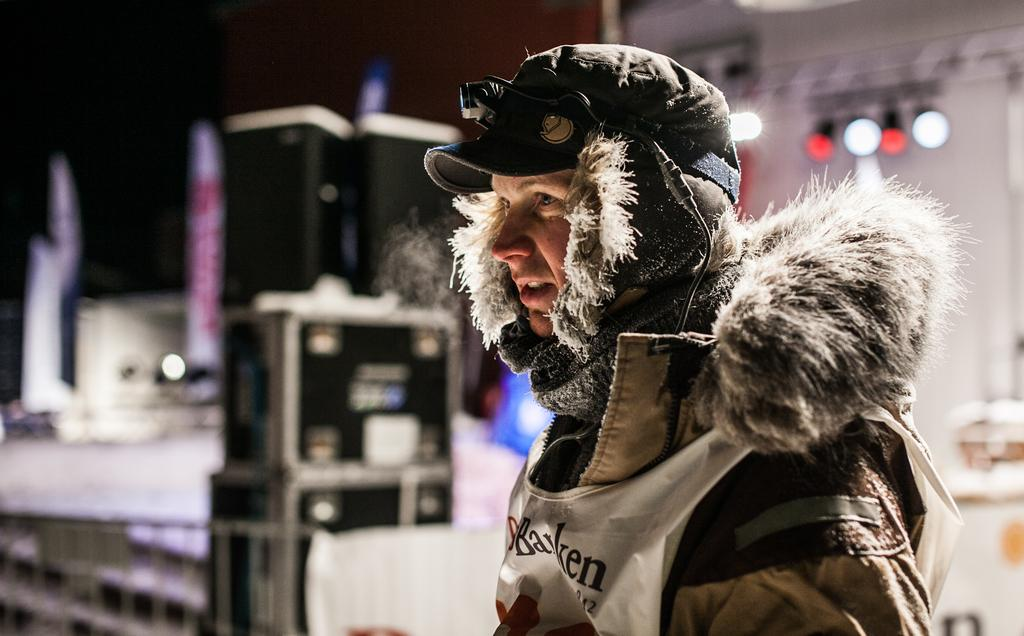Who or what is the main subject in the image? There is a person in the image. Can you describe the person's attire? The person is wearing a cap and clothes. What can be seen in the background of the image? There are blurred objects in the background of the image. What type of cakes is the person reading in the image? There is no indication in the image that the person is reading or that there are cakes present. 